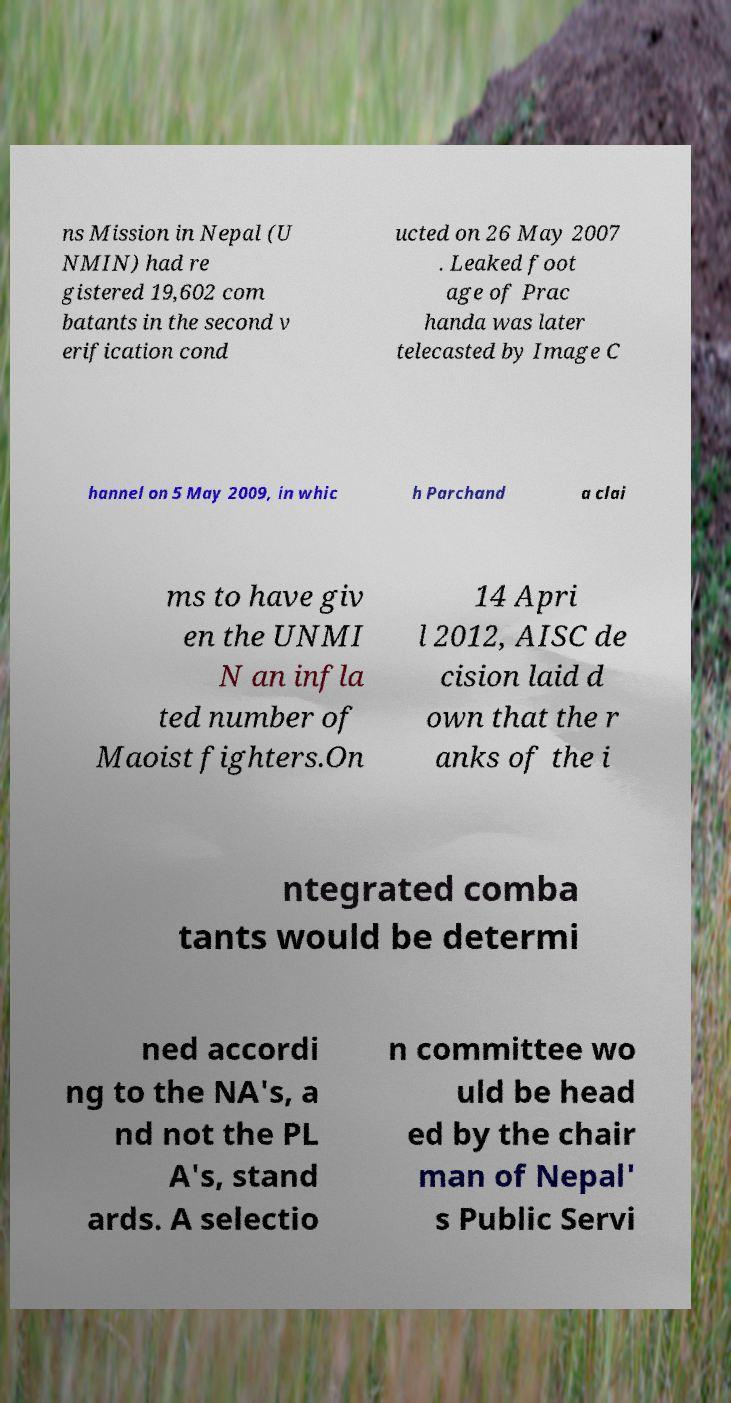There's text embedded in this image that I need extracted. Can you transcribe it verbatim? ns Mission in Nepal (U NMIN) had re gistered 19,602 com batants in the second v erification cond ucted on 26 May 2007 . Leaked foot age of Prac handa was later telecasted by Image C hannel on 5 May 2009, in whic h Parchand a clai ms to have giv en the UNMI N an infla ted number of Maoist fighters.On 14 Apri l 2012, AISC de cision laid d own that the r anks of the i ntegrated comba tants would be determi ned accordi ng to the NA's, a nd not the PL A's, stand ards. A selectio n committee wo uld be head ed by the chair man of Nepal' s Public Servi 